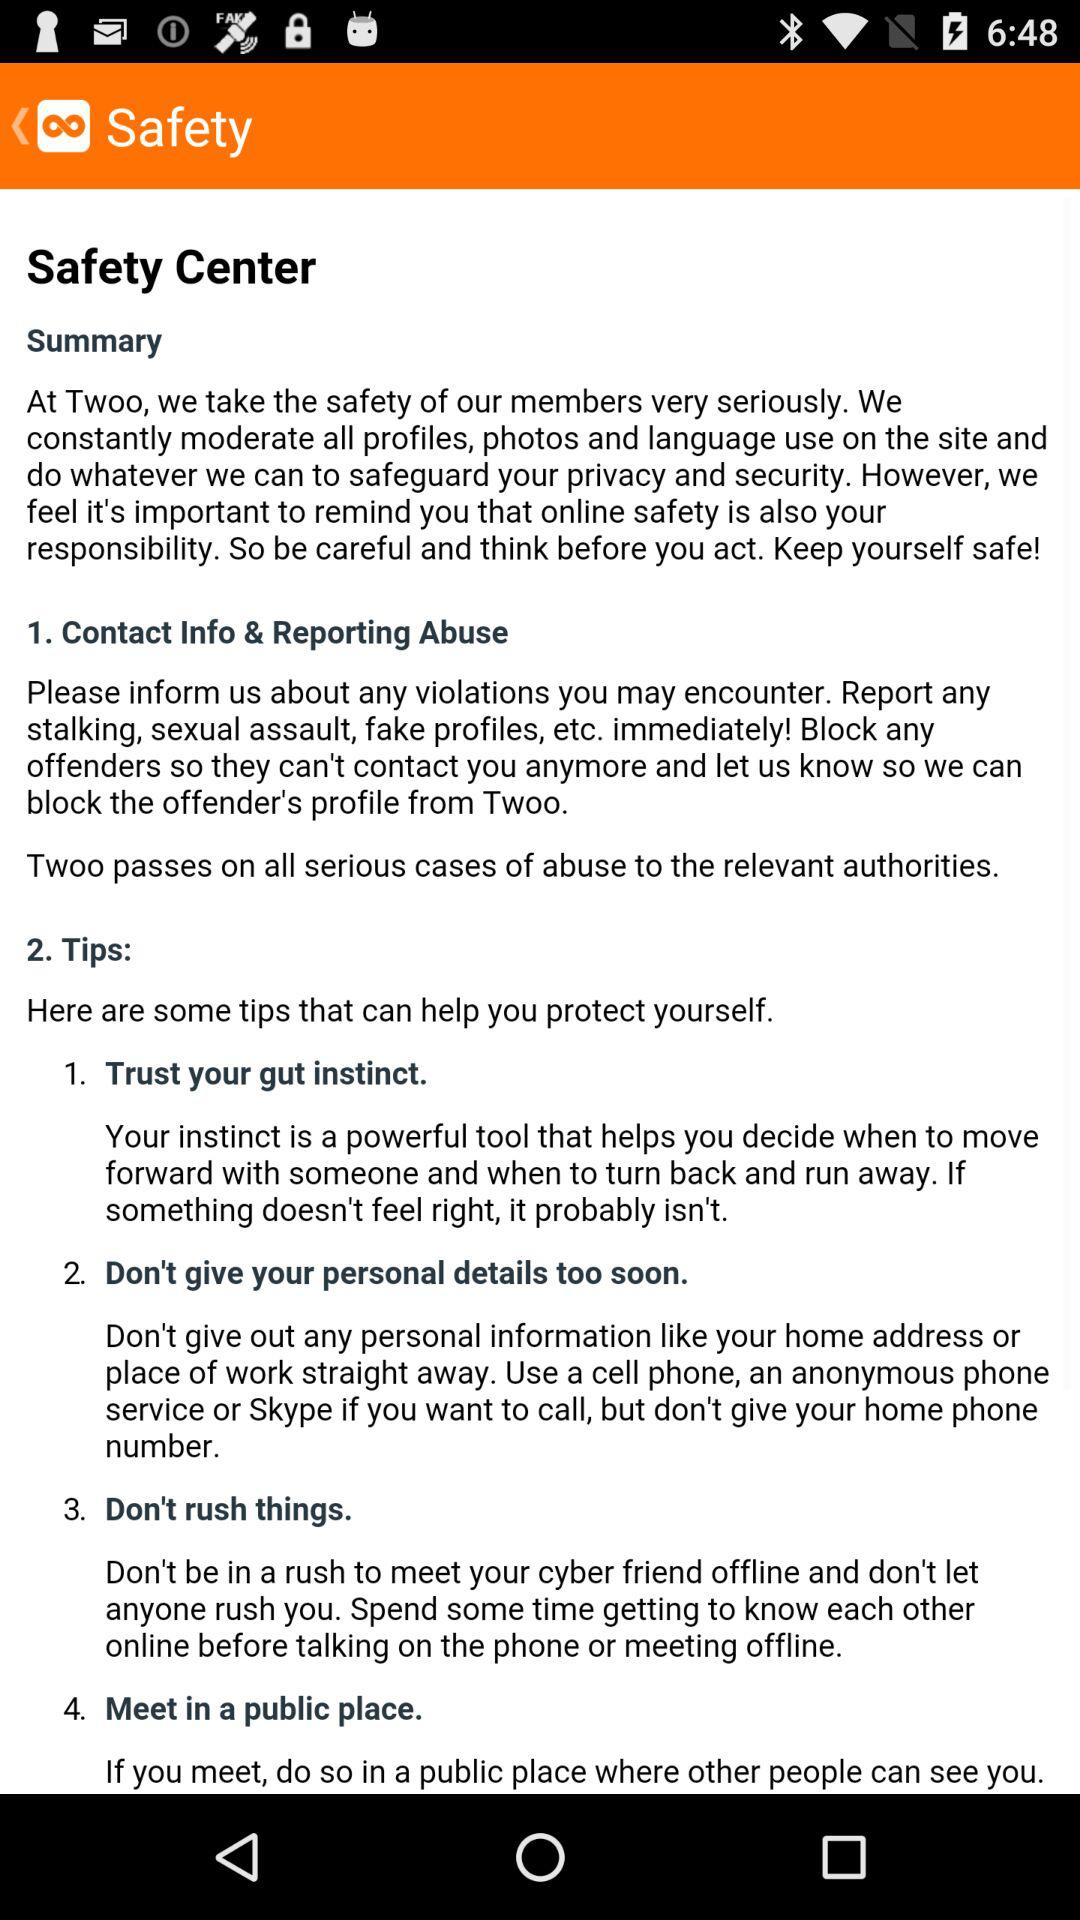What is the name of the application? The name of the application is "Twoo". 